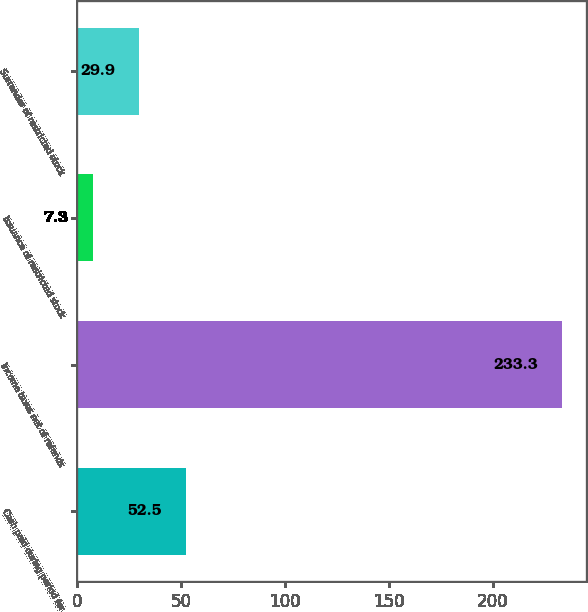Convert chart. <chart><loc_0><loc_0><loc_500><loc_500><bar_chart><fcel>Cash paid during period for<fcel>Income taxes net of refunds<fcel>Issuance of restricted stock<fcel>Surrender of restricted stock<nl><fcel>52.5<fcel>233.3<fcel>7.3<fcel>29.9<nl></chart> 